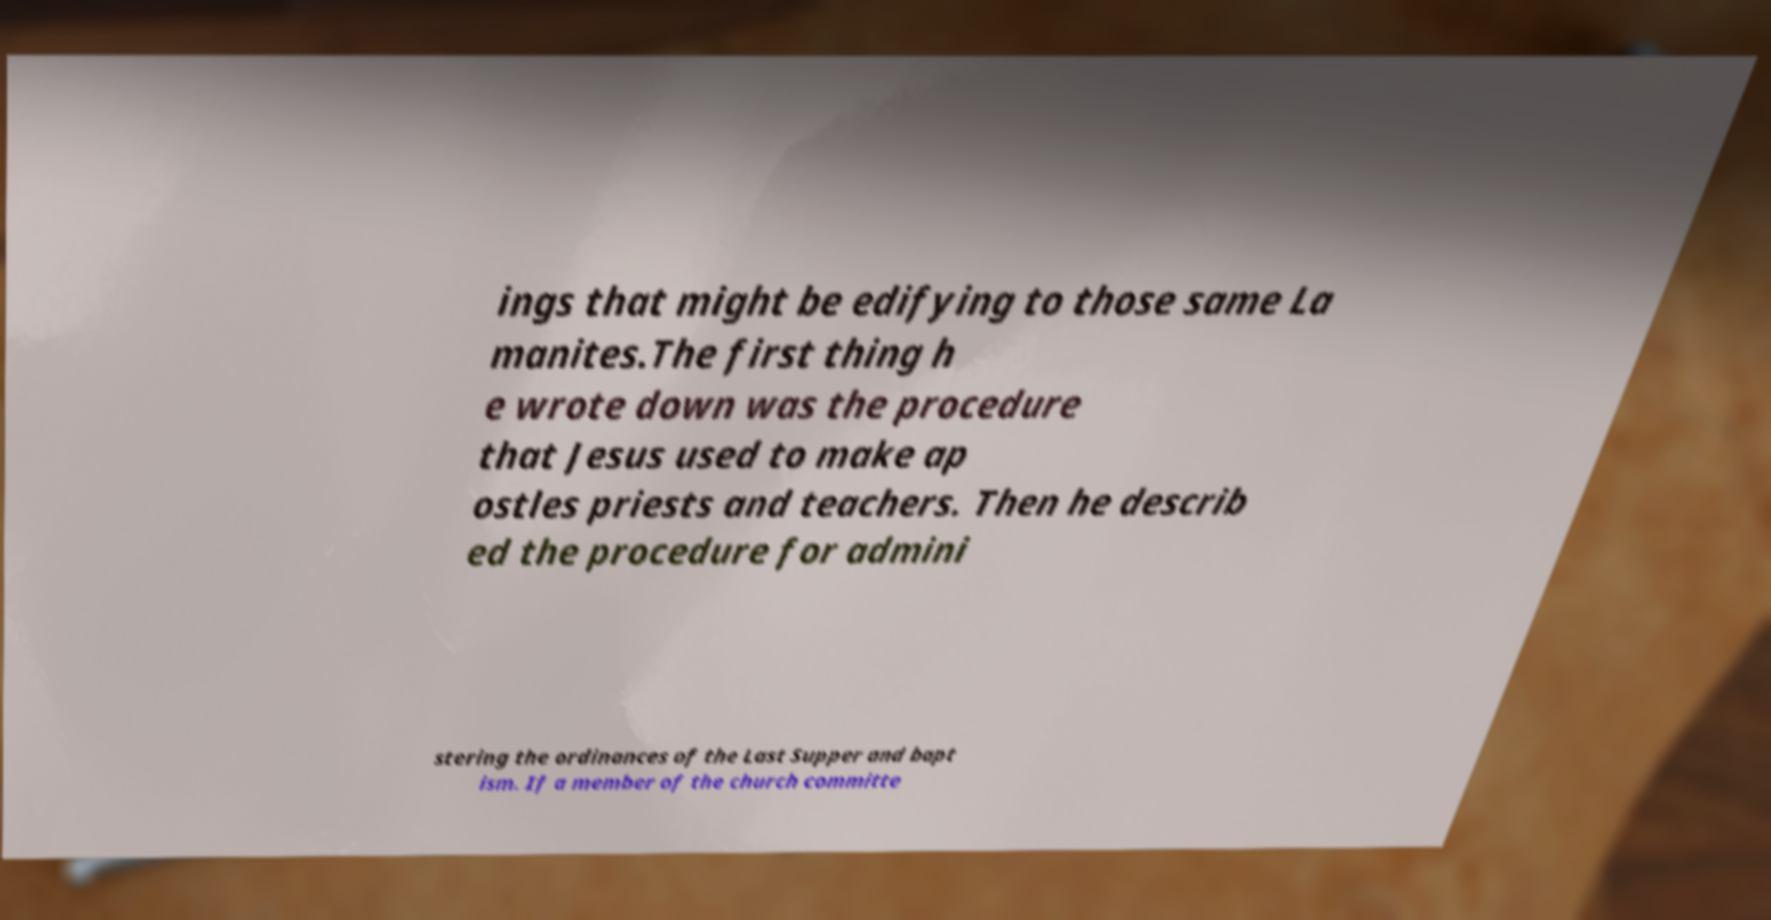Can you read and provide the text displayed in the image?This photo seems to have some interesting text. Can you extract and type it out for me? ings that might be edifying to those same La manites.The first thing h e wrote down was the procedure that Jesus used to make ap ostles priests and teachers. Then he describ ed the procedure for admini stering the ordinances of the Last Supper and bapt ism. If a member of the church committe 